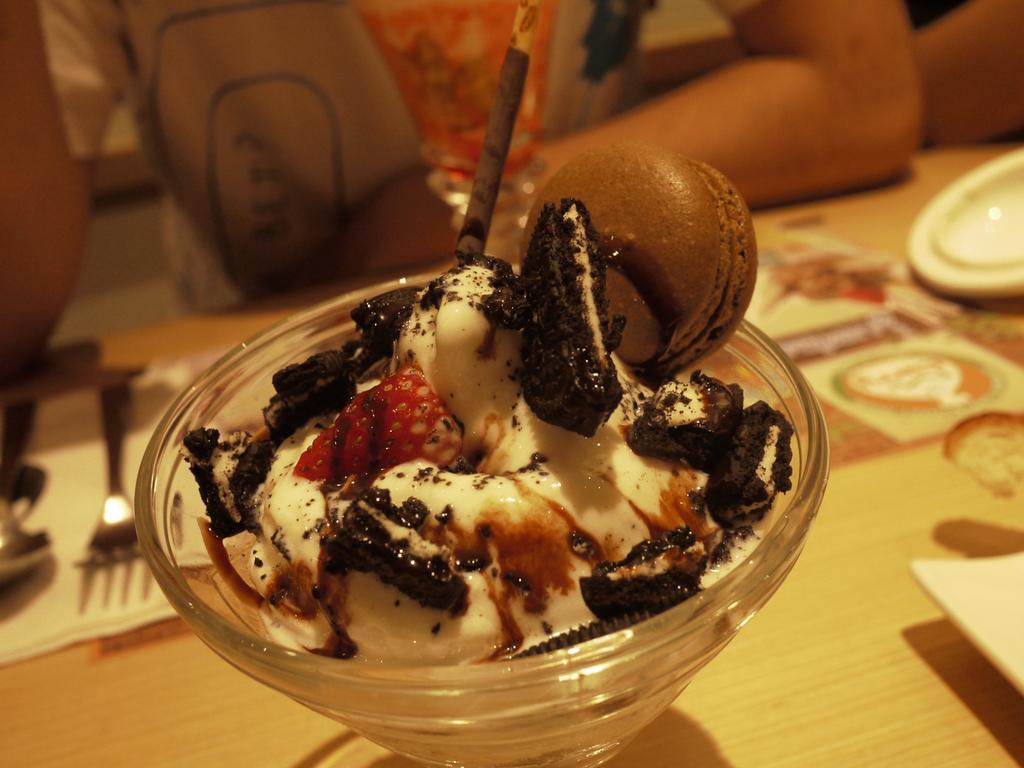How would you summarize this image in a sentence or two? In this image we can see an ice cream in a glass bowl is kept on a table. Beside it tissue, spoon and fork is present. Behind people are sitting. 